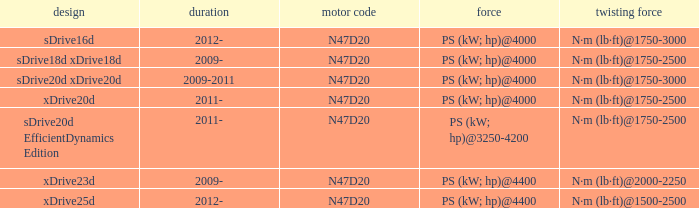What is the torque of the xdrive20d model, which has a power of ps (kw; hp)@4000? N·m (lb·ft)@1750-2500. Parse the full table. {'header': ['design', 'duration', 'motor code', 'force', 'twisting force'], 'rows': [['sDrive16d', '2012-', 'N47D20', 'PS (kW; hp)@4000', 'N·m (lb·ft)@1750-3000'], ['sDrive18d xDrive18d', '2009-', 'N47D20', 'PS (kW; hp)@4000', 'N·m (lb·ft)@1750-2500'], ['sDrive20d xDrive20d', '2009-2011', 'N47D20', 'PS (kW; hp)@4000', 'N·m (lb·ft)@1750-3000'], ['xDrive20d', '2011-', 'N47D20', 'PS (kW; hp)@4000', 'N·m (lb·ft)@1750-2500'], ['sDrive20d EfficientDynamics Edition', '2011-', 'N47D20', 'PS (kW; hp)@3250-4200', 'N·m (lb·ft)@1750-2500'], ['xDrive23d', '2009-', 'N47D20', 'PS (kW; hp)@4400', 'N·m (lb·ft)@2000-2250'], ['xDrive25d', '2012-', 'N47D20', 'PS (kW; hp)@4400', 'N·m (lb·ft)@1500-2500']]} 